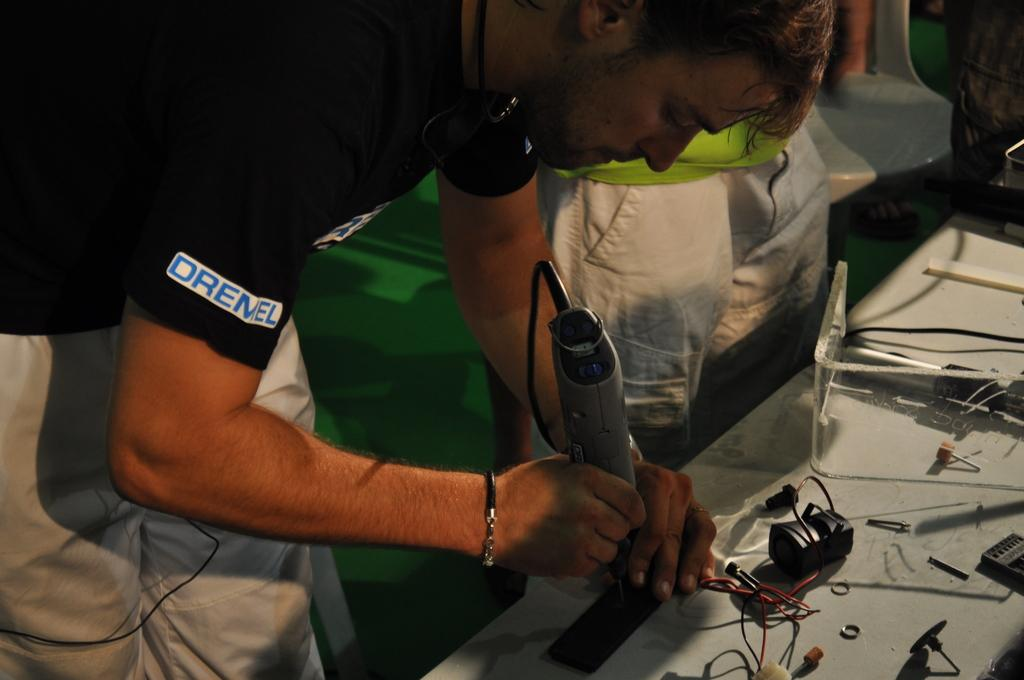<image>
Write a terse but informative summary of the picture. A man in a shirt that says Dremel uses a Dremel tool. 